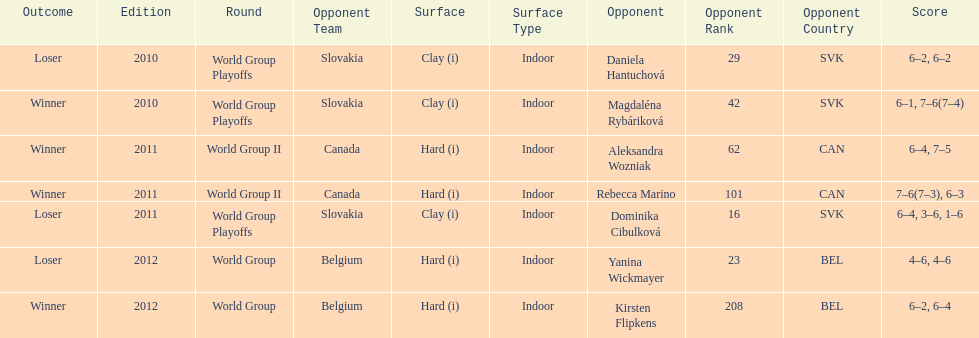Was the game versus canada later than the game versus belgium? No. 